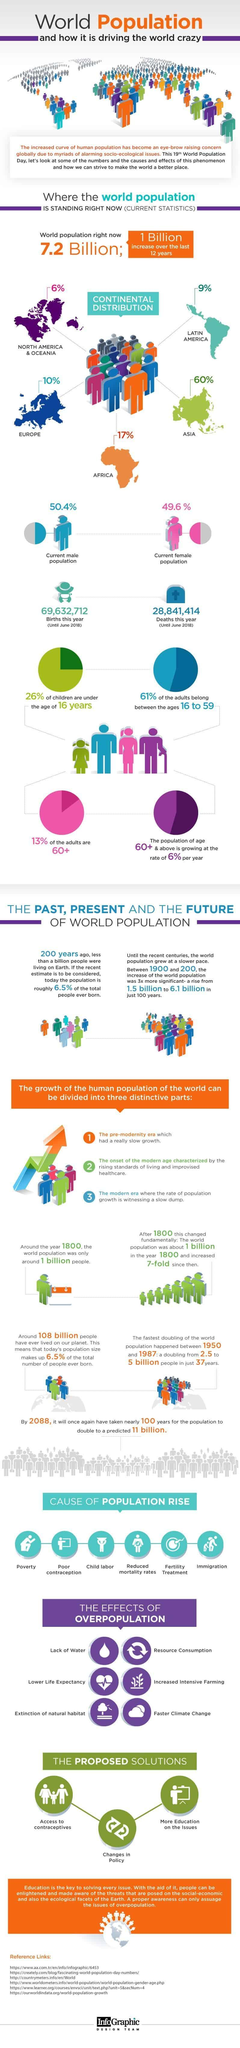What percentage of the world's population is in Europe?
Answer the question with a short phrase. 10% What percent of the adult population in the world are below 60 years? 87% What is the number of births this year until June 2018? 69,632,712 What percent of the world's population is female? 49.6% What percent of the world's population is male? 50.4% Which are the least populated continents in the world? NORTH AMERICA & OCEANIA Which is the most densely populated continent in the world? ASIA What percentage of the world's population is in Africa? 17% 